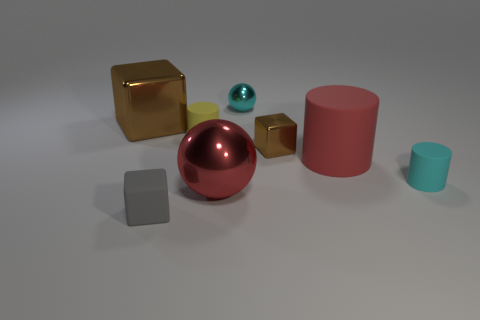What material is the tiny thing that is the same color as the tiny shiny ball?
Offer a very short reply. Rubber. Are there any other things that are the same size as the yellow matte cylinder?
Provide a succinct answer. Yes. There is a shiny sphere in front of the red cylinder; does it have the same size as the cylinder to the right of the large cylinder?
Give a very brief answer. No. The other big matte thing that is the same shape as the yellow thing is what color?
Make the answer very short. Red. Is there anything else that has the same shape as the yellow rubber object?
Give a very brief answer. Yes. Are there more matte cylinders in front of the large ball than large red rubber things on the left side of the cyan shiny ball?
Your response must be concise. No. There is a cyan thing that is to the right of the ball that is on the right side of the large ball that is behind the tiny gray rubber block; what is its size?
Provide a succinct answer. Small. Is the tiny gray block made of the same material as the red object behind the large red ball?
Give a very brief answer. Yes. Is the big red metal object the same shape as the yellow rubber thing?
Keep it short and to the point. No. What number of other objects are the same material as the large cylinder?
Your response must be concise. 3. 